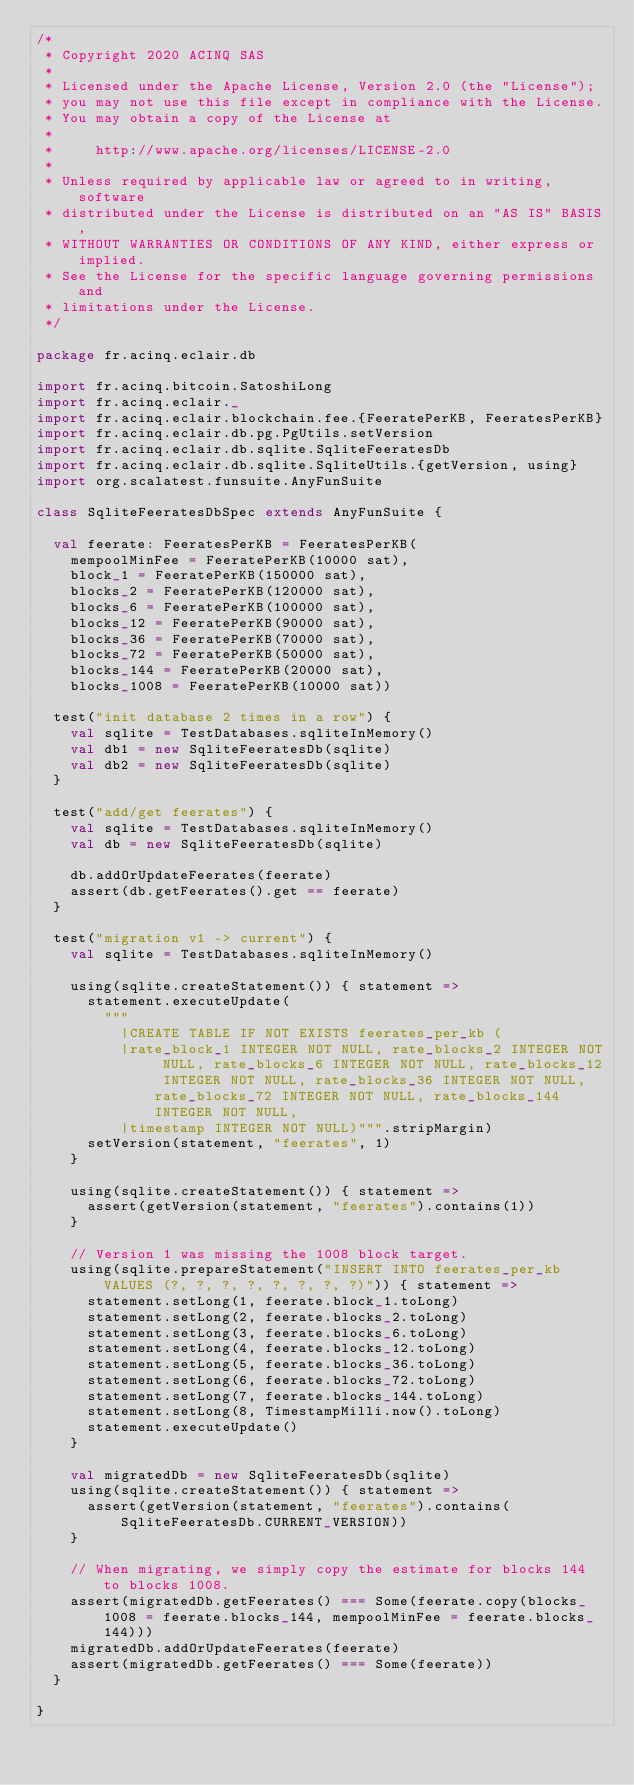Convert code to text. <code><loc_0><loc_0><loc_500><loc_500><_Scala_>/*
 * Copyright 2020 ACINQ SAS
 *
 * Licensed under the Apache License, Version 2.0 (the "License");
 * you may not use this file except in compliance with the License.
 * You may obtain a copy of the License at
 *
 *     http://www.apache.org/licenses/LICENSE-2.0
 *
 * Unless required by applicable law or agreed to in writing, software
 * distributed under the License is distributed on an "AS IS" BASIS,
 * WITHOUT WARRANTIES OR CONDITIONS OF ANY KIND, either express or implied.
 * See the License for the specific language governing permissions and
 * limitations under the License.
 */

package fr.acinq.eclair.db

import fr.acinq.bitcoin.SatoshiLong
import fr.acinq.eclair._
import fr.acinq.eclair.blockchain.fee.{FeeratePerKB, FeeratesPerKB}
import fr.acinq.eclair.db.pg.PgUtils.setVersion
import fr.acinq.eclair.db.sqlite.SqliteFeeratesDb
import fr.acinq.eclair.db.sqlite.SqliteUtils.{getVersion, using}
import org.scalatest.funsuite.AnyFunSuite

class SqliteFeeratesDbSpec extends AnyFunSuite {

  val feerate: FeeratesPerKB = FeeratesPerKB(
    mempoolMinFee = FeeratePerKB(10000 sat),
    block_1 = FeeratePerKB(150000 sat),
    blocks_2 = FeeratePerKB(120000 sat),
    blocks_6 = FeeratePerKB(100000 sat),
    blocks_12 = FeeratePerKB(90000 sat),
    blocks_36 = FeeratePerKB(70000 sat),
    blocks_72 = FeeratePerKB(50000 sat),
    blocks_144 = FeeratePerKB(20000 sat),
    blocks_1008 = FeeratePerKB(10000 sat))

  test("init database 2 times in a row") {
    val sqlite = TestDatabases.sqliteInMemory()
    val db1 = new SqliteFeeratesDb(sqlite)
    val db2 = new SqliteFeeratesDb(sqlite)
  }

  test("add/get feerates") {
    val sqlite = TestDatabases.sqliteInMemory()
    val db = new SqliteFeeratesDb(sqlite)

    db.addOrUpdateFeerates(feerate)
    assert(db.getFeerates().get == feerate)
  }

  test("migration v1 -> current") {
    val sqlite = TestDatabases.sqliteInMemory()

    using(sqlite.createStatement()) { statement =>
      statement.executeUpdate(
        """
          |CREATE TABLE IF NOT EXISTS feerates_per_kb (
          |rate_block_1 INTEGER NOT NULL, rate_blocks_2 INTEGER NOT NULL, rate_blocks_6 INTEGER NOT NULL, rate_blocks_12 INTEGER NOT NULL, rate_blocks_36 INTEGER NOT NULL, rate_blocks_72 INTEGER NOT NULL, rate_blocks_144 INTEGER NOT NULL,
          |timestamp INTEGER NOT NULL)""".stripMargin)
      setVersion(statement, "feerates", 1)
    }

    using(sqlite.createStatement()) { statement =>
      assert(getVersion(statement, "feerates").contains(1))
    }

    // Version 1 was missing the 1008 block target.
    using(sqlite.prepareStatement("INSERT INTO feerates_per_kb VALUES (?, ?, ?, ?, ?, ?, ?, ?)")) { statement =>
      statement.setLong(1, feerate.block_1.toLong)
      statement.setLong(2, feerate.blocks_2.toLong)
      statement.setLong(3, feerate.blocks_6.toLong)
      statement.setLong(4, feerate.blocks_12.toLong)
      statement.setLong(5, feerate.blocks_36.toLong)
      statement.setLong(6, feerate.blocks_72.toLong)
      statement.setLong(7, feerate.blocks_144.toLong)
      statement.setLong(8, TimestampMilli.now().toLong)
      statement.executeUpdate()
    }

    val migratedDb = new SqliteFeeratesDb(sqlite)
    using(sqlite.createStatement()) { statement =>
      assert(getVersion(statement, "feerates").contains(SqliteFeeratesDb.CURRENT_VERSION))
    }

    // When migrating, we simply copy the estimate for blocks 144 to blocks 1008.
    assert(migratedDb.getFeerates() === Some(feerate.copy(blocks_1008 = feerate.blocks_144, mempoolMinFee = feerate.blocks_144)))
    migratedDb.addOrUpdateFeerates(feerate)
    assert(migratedDb.getFeerates() === Some(feerate))
  }

}
</code> 